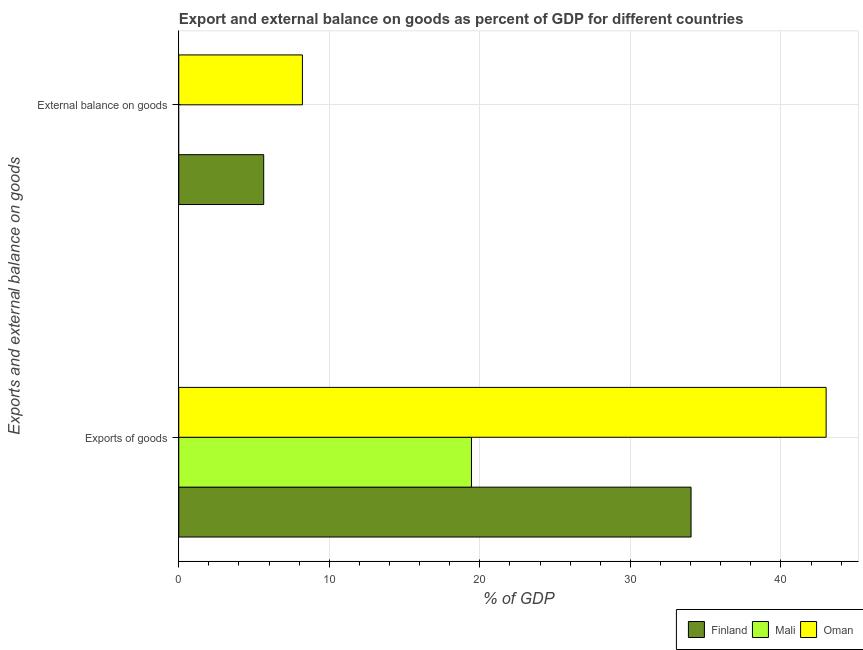Are the number of bars per tick equal to the number of legend labels?
Provide a succinct answer. No. Are the number of bars on each tick of the Y-axis equal?
Your answer should be compact. No. How many bars are there on the 2nd tick from the top?
Make the answer very short. 3. How many bars are there on the 1st tick from the bottom?
Offer a terse response. 3. What is the label of the 1st group of bars from the top?
Give a very brief answer. External balance on goods. What is the export of goods as percentage of gdp in Oman?
Provide a succinct answer. 43. Across all countries, what is the maximum external balance on goods as percentage of gdp?
Ensure brevity in your answer.  8.21. Across all countries, what is the minimum export of goods as percentage of gdp?
Your response must be concise. 19.44. In which country was the external balance on goods as percentage of gdp maximum?
Your answer should be very brief. Oman. What is the total external balance on goods as percentage of gdp in the graph?
Offer a terse response. 13.86. What is the difference between the external balance on goods as percentage of gdp in Finland and that in Oman?
Offer a very short reply. -2.57. What is the difference between the external balance on goods as percentage of gdp in Oman and the export of goods as percentage of gdp in Mali?
Give a very brief answer. -11.23. What is the average export of goods as percentage of gdp per country?
Offer a terse response. 32.16. What is the difference between the external balance on goods as percentage of gdp and export of goods as percentage of gdp in Oman?
Provide a succinct answer. -34.79. What is the ratio of the export of goods as percentage of gdp in Oman to that in Finland?
Keep it short and to the point. 1.26. Is the export of goods as percentage of gdp in Oman less than that in Mali?
Offer a very short reply. No. In how many countries, is the export of goods as percentage of gdp greater than the average export of goods as percentage of gdp taken over all countries?
Your answer should be very brief. 2. How many bars are there?
Ensure brevity in your answer.  5. Are all the bars in the graph horizontal?
Provide a short and direct response. Yes. How are the legend labels stacked?
Offer a very short reply. Horizontal. What is the title of the graph?
Give a very brief answer. Export and external balance on goods as percent of GDP for different countries. Does "Caribbean small states" appear as one of the legend labels in the graph?
Provide a succinct answer. No. What is the label or title of the X-axis?
Make the answer very short. % of GDP. What is the label or title of the Y-axis?
Provide a succinct answer. Exports and external balance on goods. What is the % of GDP of Finland in Exports of goods?
Provide a short and direct response. 34.03. What is the % of GDP in Mali in Exports of goods?
Offer a terse response. 19.44. What is the % of GDP in Oman in Exports of goods?
Keep it short and to the point. 43. What is the % of GDP of Finland in External balance on goods?
Provide a short and direct response. 5.64. What is the % of GDP in Mali in External balance on goods?
Provide a short and direct response. 0. What is the % of GDP in Oman in External balance on goods?
Give a very brief answer. 8.21. Across all Exports and external balance on goods, what is the maximum % of GDP in Finland?
Your response must be concise. 34.03. Across all Exports and external balance on goods, what is the maximum % of GDP in Mali?
Give a very brief answer. 19.44. Across all Exports and external balance on goods, what is the maximum % of GDP in Oman?
Your answer should be very brief. 43. Across all Exports and external balance on goods, what is the minimum % of GDP of Finland?
Make the answer very short. 5.64. Across all Exports and external balance on goods, what is the minimum % of GDP of Oman?
Your response must be concise. 8.21. What is the total % of GDP of Finland in the graph?
Offer a terse response. 39.67. What is the total % of GDP of Mali in the graph?
Offer a terse response. 19.44. What is the total % of GDP in Oman in the graph?
Ensure brevity in your answer.  51.21. What is the difference between the % of GDP of Finland in Exports of goods and that in External balance on goods?
Your answer should be compact. 28.39. What is the difference between the % of GDP of Oman in Exports of goods and that in External balance on goods?
Your response must be concise. 34.79. What is the difference between the % of GDP in Finland in Exports of goods and the % of GDP in Oman in External balance on goods?
Your response must be concise. 25.81. What is the difference between the % of GDP of Mali in Exports of goods and the % of GDP of Oman in External balance on goods?
Provide a short and direct response. 11.23. What is the average % of GDP in Finland per Exports and external balance on goods?
Give a very brief answer. 19.84. What is the average % of GDP in Mali per Exports and external balance on goods?
Your response must be concise. 9.72. What is the average % of GDP of Oman per Exports and external balance on goods?
Offer a terse response. 25.61. What is the difference between the % of GDP of Finland and % of GDP of Mali in Exports of goods?
Offer a terse response. 14.59. What is the difference between the % of GDP of Finland and % of GDP of Oman in Exports of goods?
Provide a short and direct response. -8.97. What is the difference between the % of GDP of Mali and % of GDP of Oman in Exports of goods?
Ensure brevity in your answer.  -23.56. What is the difference between the % of GDP of Finland and % of GDP of Oman in External balance on goods?
Your answer should be compact. -2.57. What is the ratio of the % of GDP in Finland in Exports of goods to that in External balance on goods?
Keep it short and to the point. 6.03. What is the ratio of the % of GDP in Oman in Exports of goods to that in External balance on goods?
Make the answer very short. 5.24. What is the difference between the highest and the second highest % of GDP of Finland?
Give a very brief answer. 28.39. What is the difference between the highest and the second highest % of GDP of Oman?
Provide a succinct answer. 34.79. What is the difference between the highest and the lowest % of GDP of Finland?
Your answer should be compact. 28.39. What is the difference between the highest and the lowest % of GDP of Mali?
Give a very brief answer. 19.44. What is the difference between the highest and the lowest % of GDP in Oman?
Your response must be concise. 34.79. 